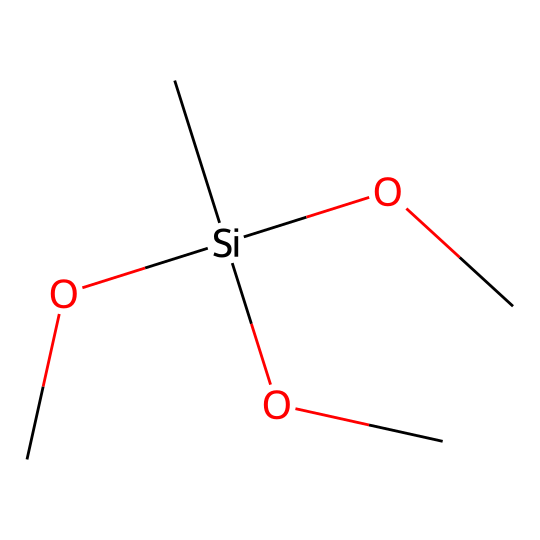How many carbon atoms are in this chemical? In the provided SMILES representation, the "C" indicates the presence of carbon atoms. There are four instances of "C" in the structure, which corresponds to four carbon atoms.
Answer: four What type of functional groups are present in this silane? The SMILES shows "OC" groups, indicating that there are three methoxy (-OCH3) groups present, which are functional groups in this silane.
Answer: methoxy How many silicon atoms are in this structure? The "Si" in the SMILES indicates a single silicon atom present in the chemical structure.
Answer: one What is the total number of oxygen atoms in this compound? The "O" in the SMILES appears three times, corresponding to three oxygen atoms associated with the three methoxy groups.
Answer: three What molecule class does this compound belong to? Since the structure is based on silicon with organic groups attached, it is classified as a silane.
Answer: silane What physical property might this silane contribute to in automotive care products? The presence of methoxy groups suggests that this silane may enhance water repellency, thereby improving the paint's protection.
Answer: water repellency What is the significance of the methoxy groups in silanes for paint preservation? The methoxy groups can help form a protective layer on the paint surface, enhancing durability and resistance to environmental damage.
Answer: protective layer 